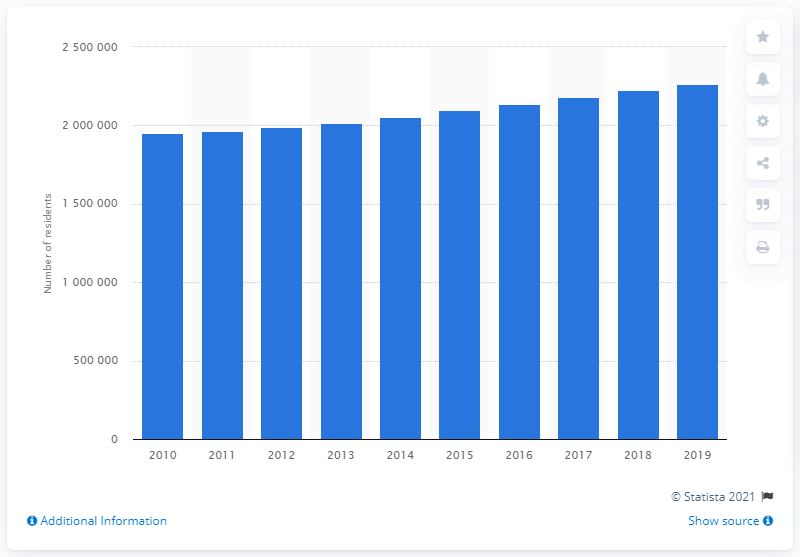How many people lived in the Las Vegas-Henderson-Paradise metropolitan area in 2019?
 2266715 